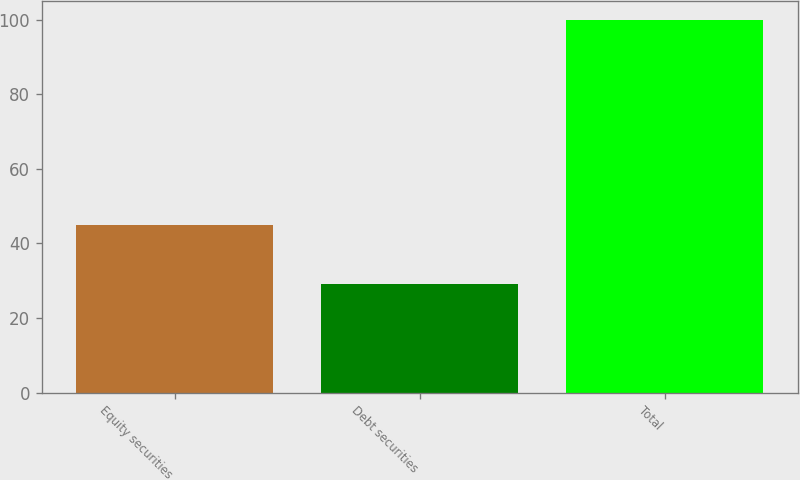Convert chart to OTSL. <chart><loc_0><loc_0><loc_500><loc_500><bar_chart><fcel>Equity securities<fcel>Debt securities<fcel>Total<nl><fcel>45<fcel>29<fcel>100<nl></chart> 